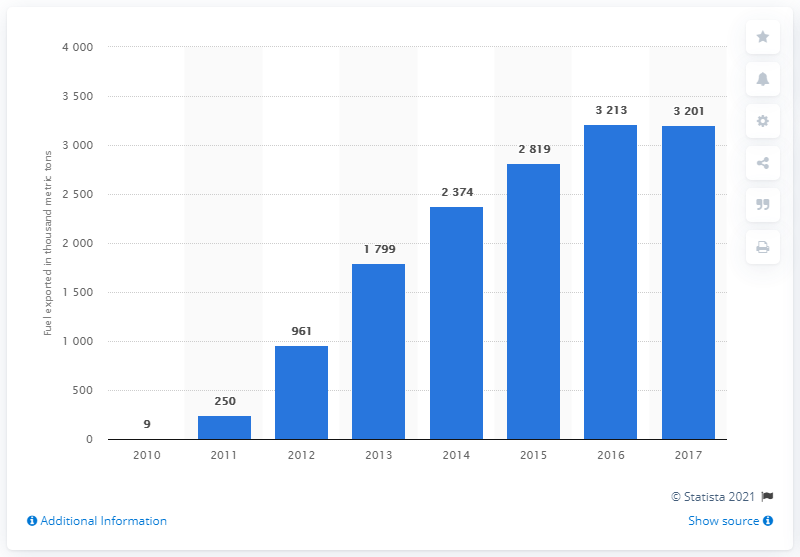Point out several critical features in this image. Refuse-derived fuel was exported from England and Wales in 2010. 